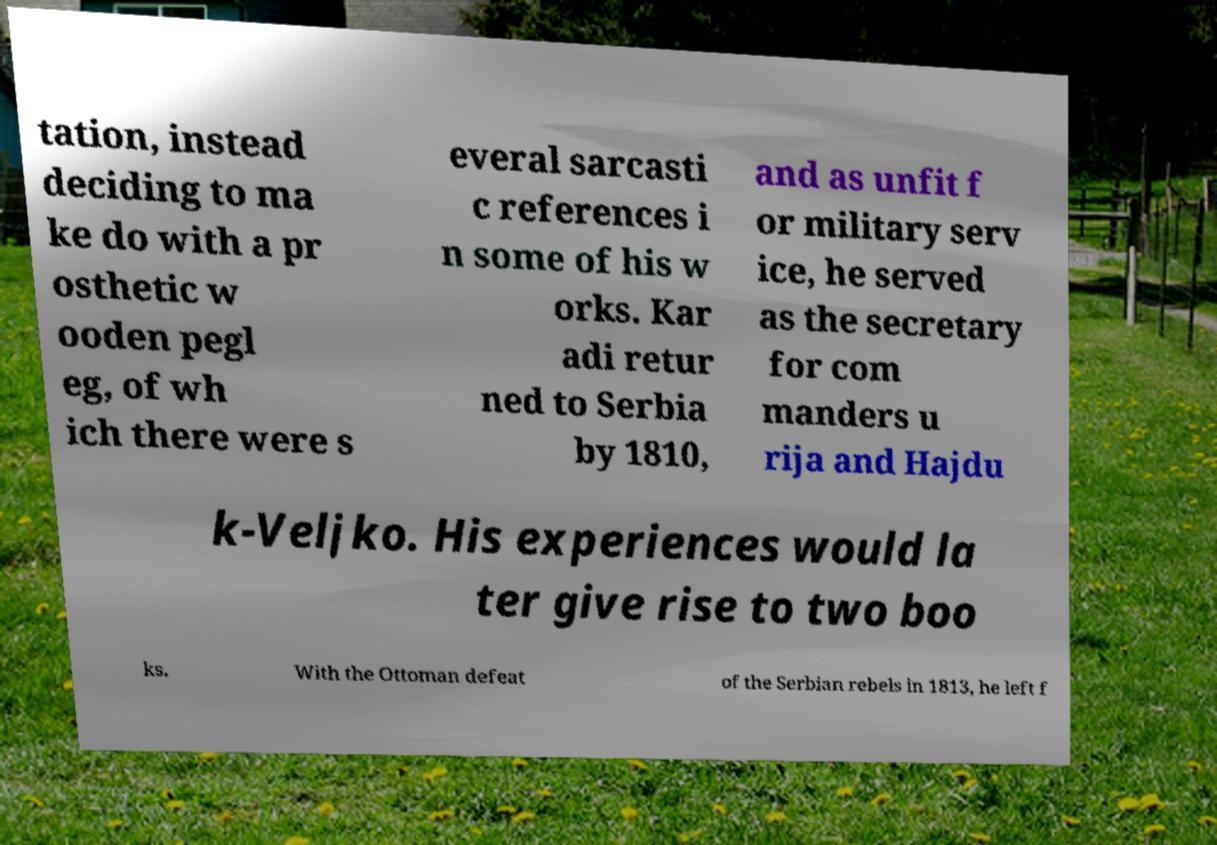For documentation purposes, I need the text within this image transcribed. Could you provide that? tation, instead deciding to ma ke do with a pr osthetic w ooden pegl eg, of wh ich there were s everal sarcasti c references i n some of his w orks. Kar adi retur ned to Serbia by 1810, and as unfit f or military serv ice, he served as the secretary for com manders u rija and Hajdu k-Veljko. His experiences would la ter give rise to two boo ks. With the Ottoman defeat of the Serbian rebels in 1813, he left f 